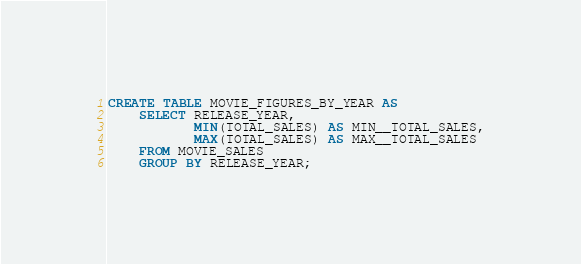<code> <loc_0><loc_0><loc_500><loc_500><_SQL_>CREATE TABLE MOVIE_FIGURES_BY_YEAR AS
    SELECT RELEASE_YEAR,
           MIN(TOTAL_SALES) AS MIN__TOTAL_SALES,
           MAX(TOTAL_SALES) AS MAX__TOTAL_SALES
    FROM MOVIE_SALES
    GROUP BY RELEASE_YEAR;
</code> 